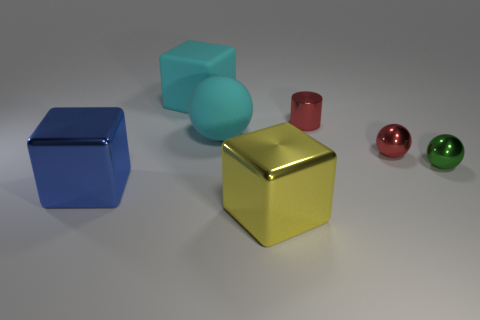What number of other large objects are made of the same material as the big yellow object?
Provide a succinct answer. 1. What color is the thing that is made of the same material as the large cyan sphere?
Your answer should be compact. Cyan. There is a metal object on the left side of the yellow thing; does it have the same color as the cylinder?
Keep it short and to the point. No. There is a red thing in front of the red cylinder; what is its material?
Offer a very short reply. Metal. Is the number of big yellow metal cubes that are on the left side of the cylinder the same as the number of large cyan cubes?
Provide a short and direct response. Yes. How many big metallic cubes are the same color as the matte sphere?
Your answer should be very brief. 0. There is another large metal thing that is the same shape as the large blue thing; what is its color?
Ensure brevity in your answer.  Yellow. Does the green metal ball have the same size as the red metallic cylinder?
Provide a succinct answer. Yes. Are there the same number of tiny red shiny objects that are in front of the shiny cylinder and cyan cubes that are to the right of the matte sphere?
Ensure brevity in your answer.  No. Are there any big cyan matte blocks?
Make the answer very short. Yes. 